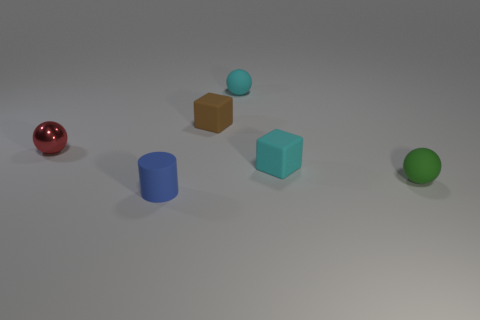How many large objects are either blocks or red metal things?
Provide a short and direct response. 0. What is the material of the tiny object that is to the left of the small thing in front of the tiny green matte ball?
Offer a terse response. Metal. What number of metallic objects are green things or tiny blocks?
Give a very brief answer. 0. What color is the other metallic object that is the same shape as the green object?
Make the answer very short. Red. There is a tiny rubber block that is to the right of the small brown rubber thing; are there any cyan spheres on the right side of it?
Provide a succinct answer. No. What number of objects are both behind the blue matte cylinder and to the right of the tiny red object?
Your response must be concise. 4. How many blue spheres are the same material as the tiny cylinder?
Keep it short and to the point. 0. How big is the object to the left of the tiny matte thing that is to the left of the tiny brown rubber object?
Ensure brevity in your answer.  Small. Are there any small cyan rubber things that have the same shape as the tiny red metal object?
Offer a terse response. Yes. Is the number of balls in front of the cyan cube less than the number of green balls that are in front of the blue matte cylinder?
Offer a very short reply. No. 